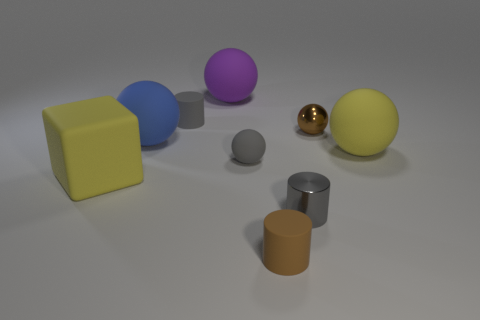Subtract all blue spheres. How many spheres are left? 4 Subtract all purple spheres. How many spheres are left? 4 Subtract all cyan spheres. Subtract all yellow cylinders. How many spheres are left? 5 Add 1 tiny brown metallic spheres. How many objects exist? 10 Subtract all cylinders. How many objects are left? 6 Subtract 0 green spheres. How many objects are left? 9 Subtract all metallic balls. Subtract all small brown rubber cylinders. How many objects are left? 7 Add 8 small brown metal balls. How many small brown metal balls are left? 9 Add 5 small brown matte spheres. How many small brown matte spheres exist? 5 